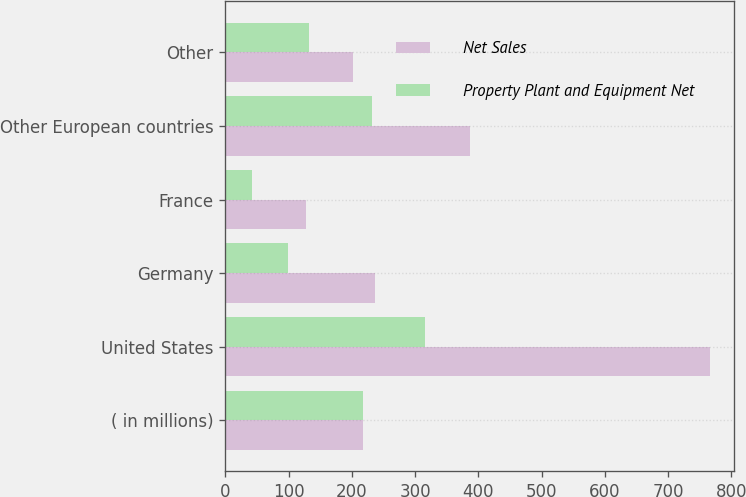<chart> <loc_0><loc_0><loc_500><loc_500><stacked_bar_chart><ecel><fcel>( in millions)<fcel>United States<fcel>Germany<fcel>France<fcel>Other European countries<fcel>Other<nl><fcel>Net Sales<fcel>217.15<fcel>766.1<fcel>235.9<fcel>127.5<fcel>386.1<fcel>201.8<nl><fcel>Property Plant and Equipment Net<fcel>217.15<fcel>315.3<fcel>99.3<fcel>42.5<fcel>232.5<fcel>132.4<nl></chart> 